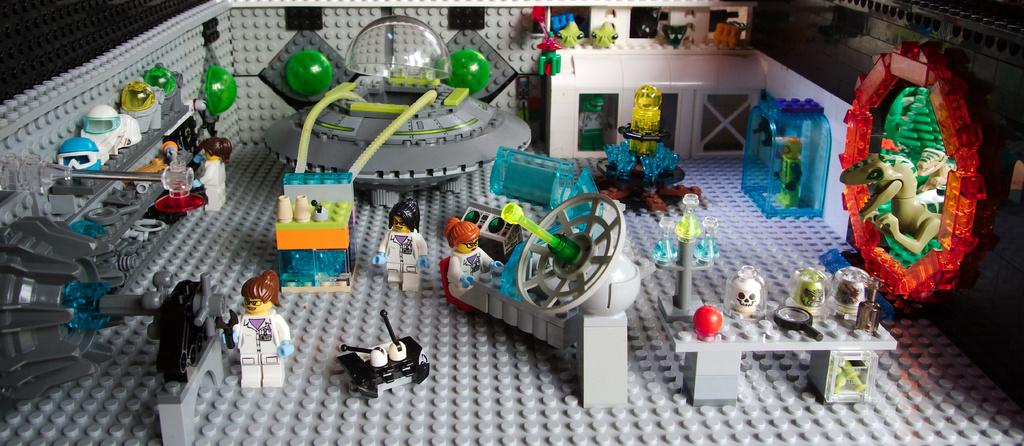What is the main activity or subject in the image? There is a Lego puzzle in the image. Who or what else is present in the image? There are people and animals in the image. What protective gear can be seen in the image? There are helmets in the image. What type of beverage container is present in the image? There are cups in the image. Can you describe any other objects in the image? There are other objects in the image, but their specific details are not mentioned in the provided facts. What type of lumber is being used to construct the Lego puzzle in the image? There is no lumber present in the image; it is a Lego puzzle made of plastic pieces. What type of cloth is being used by the people in the image? The provided facts do not mention any specific type of cloth worn by the people in the image. 